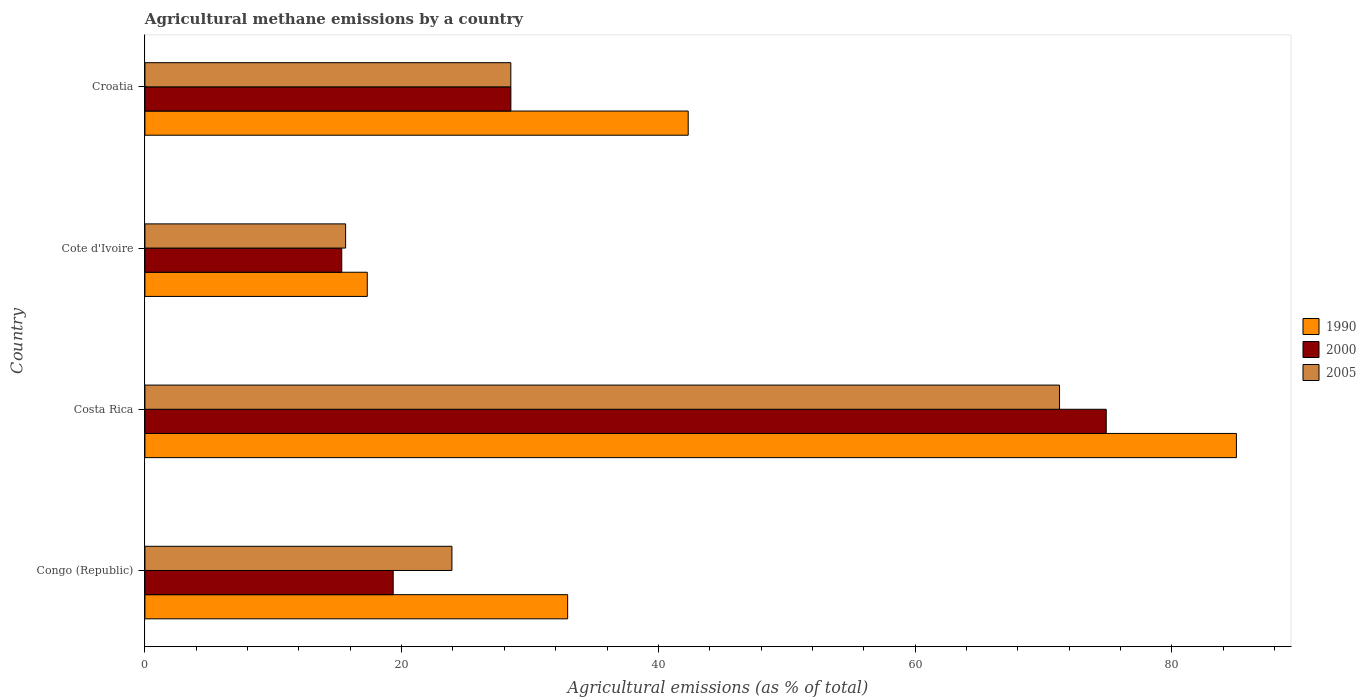How many different coloured bars are there?
Your answer should be compact. 3. How many groups of bars are there?
Make the answer very short. 4. How many bars are there on the 1st tick from the top?
Keep it short and to the point. 3. What is the label of the 2nd group of bars from the top?
Keep it short and to the point. Cote d'Ivoire. In how many cases, is the number of bars for a given country not equal to the number of legend labels?
Provide a short and direct response. 0. What is the amount of agricultural methane emitted in 1990 in Croatia?
Your response must be concise. 42.33. Across all countries, what is the maximum amount of agricultural methane emitted in 2000?
Keep it short and to the point. 74.89. Across all countries, what is the minimum amount of agricultural methane emitted in 2000?
Give a very brief answer. 15.33. In which country was the amount of agricultural methane emitted in 2005 maximum?
Offer a terse response. Costa Rica. In which country was the amount of agricultural methane emitted in 2000 minimum?
Give a very brief answer. Cote d'Ivoire. What is the total amount of agricultural methane emitted in 2005 in the graph?
Give a very brief answer. 139.32. What is the difference between the amount of agricultural methane emitted in 1990 in Congo (Republic) and that in Cote d'Ivoire?
Ensure brevity in your answer.  15.61. What is the difference between the amount of agricultural methane emitted in 2000 in Cote d'Ivoire and the amount of agricultural methane emitted in 1990 in Costa Rica?
Your answer should be compact. -69.7. What is the average amount of agricultural methane emitted in 2005 per country?
Your response must be concise. 34.83. What is the difference between the amount of agricultural methane emitted in 2000 and amount of agricultural methane emitted in 1990 in Congo (Republic)?
Provide a short and direct response. -13.59. In how many countries, is the amount of agricultural methane emitted in 2000 greater than 28 %?
Ensure brevity in your answer.  2. What is the ratio of the amount of agricultural methane emitted in 2005 in Costa Rica to that in Croatia?
Offer a very short reply. 2.5. What is the difference between the highest and the second highest amount of agricultural methane emitted in 2005?
Make the answer very short. 42.75. What is the difference between the highest and the lowest amount of agricultural methane emitted in 2005?
Offer a terse response. 55.62. Is the sum of the amount of agricultural methane emitted in 1990 in Congo (Republic) and Croatia greater than the maximum amount of agricultural methane emitted in 2000 across all countries?
Offer a terse response. Yes. What does the 3rd bar from the top in Cote d'Ivoire represents?
Your answer should be compact. 1990. What does the 2nd bar from the bottom in Cote d'Ivoire represents?
Provide a succinct answer. 2000. Is it the case that in every country, the sum of the amount of agricultural methane emitted in 1990 and amount of agricultural methane emitted in 2005 is greater than the amount of agricultural methane emitted in 2000?
Keep it short and to the point. Yes. Are all the bars in the graph horizontal?
Your response must be concise. Yes. How many countries are there in the graph?
Offer a very short reply. 4. Where does the legend appear in the graph?
Keep it short and to the point. Center right. How many legend labels are there?
Your answer should be very brief. 3. How are the legend labels stacked?
Your answer should be compact. Vertical. What is the title of the graph?
Ensure brevity in your answer.  Agricultural methane emissions by a country. Does "1967" appear as one of the legend labels in the graph?
Your answer should be compact. No. What is the label or title of the X-axis?
Your response must be concise. Agricultural emissions (as % of total). What is the label or title of the Y-axis?
Make the answer very short. Country. What is the Agricultural emissions (as % of total) in 1990 in Congo (Republic)?
Provide a succinct answer. 32.93. What is the Agricultural emissions (as % of total) in 2000 in Congo (Republic)?
Offer a terse response. 19.34. What is the Agricultural emissions (as % of total) in 2005 in Congo (Republic)?
Give a very brief answer. 23.92. What is the Agricultural emissions (as % of total) of 1990 in Costa Rica?
Your answer should be very brief. 85.04. What is the Agricultural emissions (as % of total) in 2000 in Costa Rica?
Keep it short and to the point. 74.89. What is the Agricultural emissions (as % of total) in 2005 in Costa Rica?
Give a very brief answer. 71.26. What is the Agricultural emissions (as % of total) of 1990 in Cote d'Ivoire?
Provide a succinct answer. 17.32. What is the Agricultural emissions (as % of total) of 2000 in Cote d'Ivoire?
Your response must be concise. 15.33. What is the Agricultural emissions (as % of total) in 2005 in Cote d'Ivoire?
Your response must be concise. 15.64. What is the Agricultural emissions (as % of total) in 1990 in Croatia?
Give a very brief answer. 42.33. What is the Agricultural emissions (as % of total) of 2000 in Croatia?
Your answer should be compact. 28.51. What is the Agricultural emissions (as % of total) of 2005 in Croatia?
Offer a very short reply. 28.51. Across all countries, what is the maximum Agricultural emissions (as % of total) of 1990?
Offer a very short reply. 85.04. Across all countries, what is the maximum Agricultural emissions (as % of total) of 2000?
Ensure brevity in your answer.  74.89. Across all countries, what is the maximum Agricultural emissions (as % of total) of 2005?
Provide a succinct answer. 71.26. Across all countries, what is the minimum Agricultural emissions (as % of total) of 1990?
Provide a short and direct response. 17.32. Across all countries, what is the minimum Agricultural emissions (as % of total) of 2000?
Make the answer very short. 15.33. Across all countries, what is the minimum Agricultural emissions (as % of total) in 2005?
Your answer should be compact. 15.64. What is the total Agricultural emissions (as % of total) of 1990 in the graph?
Your answer should be compact. 177.62. What is the total Agricultural emissions (as % of total) in 2000 in the graph?
Provide a short and direct response. 138.08. What is the total Agricultural emissions (as % of total) of 2005 in the graph?
Provide a succinct answer. 139.32. What is the difference between the Agricultural emissions (as % of total) of 1990 in Congo (Republic) and that in Costa Rica?
Offer a terse response. -52.1. What is the difference between the Agricultural emissions (as % of total) in 2000 in Congo (Republic) and that in Costa Rica?
Your answer should be very brief. -55.55. What is the difference between the Agricultural emissions (as % of total) of 2005 in Congo (Republic) and that in Costa Rica?
Provide a short and direct response. -47.34. What is the difference between the Agricultural emissions (as % of total) of 1990 in Congo (Republic) and that in Cote d'Ivoire?
Provide a short and direct response. 15.61. What is the difference between the Agricultural emissions (as % of total) in 2000 in Congo (Republic) and that in Cote d'Ivoire?
Ensure brevity in your answer.  4.01. What is the difference between the Agricultural emissions (as % of total) of 2005 in Congo (Republic) and that in Cote d'Ivoire?
Make the answer very short. 8.28. What is the difference between the Agricultural emissions (as % of total) in 1990 in Congo (Republic) and that in Croatia?
Your answer should be very brief. -9.39. What is the difference between the Agricultural emissions (as % of total) of 2000 in Congo (Republic) and that in Croatia?
Keep it short and to the point. -9.17. What is the difference between the Agricultural emissions (as % of total) of 2005 in Congo (Republic) and that in Croatia?
Offer a very short reply. -4.59. What is the difference between the Agricultural emissions (as % of total) of 1990 in Costa Rica and that in Cote d'Ivoire?
Keep it short and to the point. 67.71. What is the difference between the Agricultural emissions (as % of total) in 2000 in Costa Rica and that in Cote d'Ivoire?
Keep it short and to the point. 59.56. What is the difference between the Agricultural emissions (as % of total) in 2005 in Costa Rica and that in Cote d'Ivoire?
Offer a very short reply. 55.62. What is the difference between the Agricultural emissions (as % of total) of 1990 in Costa Rica and that in Croatia?
Provide a short and direct response. 42.71. What is the difference between the Agricultural emissions (as % of total) of 2000 in Costa Rica and that in Croatia?
Make the answer very short. 46.38. What is the difference between the Agricultural emissions (as % of total) of 2005 in Costa Rica and that in Croatia?
Provide a succinct answer. 42.75. What is the difference between the Agricultural emissions (as % of total) of 1990 in Cote d'Ivoire and that in Croatia?
Make the answer very short. -25. What is the difference between the Agricultural emissions (as % of total) in 2000 in Cote d'Ivoire and that in Croatia?
Your response must be concise. -13.18. What is the difference between the Agricultural emissions (as % of total) of 2005 in Cote d'Ivoire and that in Croatia?
Give a very brief answer. -12.87. What is the difference between the Agricultural emissions (as % of total) in 1990 in Congo (Republic) and the Agricultural emissions (as % of total) in 2000 in Costa Rica?
Give a very brief answer. -41.96. What is the difference between the Agricultural emissions (as % of total) of 1990 in Congo (Republic) and the Agricultural emissions (as % of total) of 2005 in Costa Rica?
Provide a succinct answer. -38.32. What is the difference between the Agricultural emissions (as % of total) of 2000 in Congo (Republic) and the Agricultural emissions (as % of total) of 2005 in Costa Rica?
Offer a terse response. -51.91. What is the difference between the Agricultural emissions (as % of total) in 1990 in Congo (Republic) and the Agricultural emissions (as % of total) in 2000 in Cote d'Ivoire?
Make the answer very short. 17.6. What is the difference between the Agricultural emissions (as % of total) in 1990 in Congo (Republic) and the Agricultural emissions (as % of total) in 2005 in Cote d'Ivoire?
Give a very brief answer. 17.3. What is the difference between the Agricultural emissions (as % of total) of 2000 in Congo (Republic) and the Agricultural emissions (as % of total) of 2005 in Cote d'Ivoire?
Offer a very short reply. 3.71. What is the difference between the Agricultural emissions (as % of total) in 1990 in Congo (Republic) and the Agricultural emissions (as % of total) in 2000 in Croatia?
Your response must be concise. 4.42. What is the difference between the Agricultural emissions (as % of total) in 1990 in Congo (Republic) and the Agricultural emissions (as % of total) in 2005 in Croatia?
Provide a succinct answer. 4.43. What is the difference between the Agricultural emissions (as % of total) in 2000 in Congo (Republic) and the Agricultural emissions (as % of total) in 2005 in Croatia?
Your answer should be very brief. -9.16. What is the difference between the Agricultural emissions (as % of total) of 1990 in Costa Rica and the Agricultural emissions (as % of total) of 2000 in Cote d'Ivoire?
Keep it short and to the point. 69.7. What is the difference between the Agricultural emissions (as % of total) of 1990 in Costa Rica and the Agricultural emissions (as % of total) of 2005 in Cote d'Ivoire?
Your answer should be very brief. 69.4. What is the difference between the Agricultural emissions (as % of total) in 2000 in Costa Rica and the Agricultural emissions (as % of total) in 2005 in Cote d'Ivoire?
Your answer should be compact. 59.26. What is the difference between the Agricultural emissions (as % of total) of 1990 in Costa Rica and the Agricultural emissions (as % of total) of 2000 in Croatia?
Provide a short and direct response. 56.53. What is the difference between the Agricultural emissions (as % of total) in 1990 in Costa Rica and the Agricultural emissions (as % of total) in 2005 in Croatia?
Offer a very short reply. 56.53. What is the difference between the Agricultural emissions (as % of total) in 2000 in Costa Rica and the Agricultural emissions (as % of total) in 2005 in Croatia?
Make the answer very short. 46.39. What is the difference between the Agricultural emissions (as % of total) in 1990 in Cote d'Ivoire and the Agricultural emissions (as % of total) in 2000 in Croatia?
Keep it short and to the point. -11.19. What is the difference between the Agricultural emissions (as % of total) in 1990 in Cote d'Ivoire and the Agricultural emissions (as % of total) in 2005 in Croatia?
Make the answer very short. -11.18. What is the difference between the Agricultural emissions (as % of total) of 2000 in Cote d'Ivoire and the Agricultural emissions (as % of total) of 2005 in Croatia?
Your response must be concise. -13.17. What is the average Agricultural emissions (as % of total) in 1990 per country?
Make the answer very short. 44.41. What is the average Agricultural emissions (as % of total) in 2000 per country?
Your answer should be very brief. 34.52. What is the average Agricultural emissions (as % of total) of 2005 per country?
Ensure brevity in your answer.  34.83. What is the difference between the Agricultural emissions (as % of total) of 1990 and Agricultural emissions (as % of total) of 2000 in Congo (Republic)?
Your answer should be compact. 13.59. What is the difference between the Agricultural emissions (as % of total) in 1990 and Agricultural emissions (as % of total) in 2005 in Congo (Republic)?
Offer a terse response. 9.02. What is the difference between the Agricultural emissions (as % of total) in 2000 and Agricultural emissions (as % of total) in 2005 in Congo (Republic)?
Your answer should be compact. -4.58. What is the difference between the Agricultural emissions (as % of total) of 1990 and Agricultural emissions (as % of total) of 2000 in Costa Rica?
Ensure brevity in your answer.  10.14. What is the difference between the Agricultural emissions (as % of total) of 1990 and Agricultural emissions (as % of total) of 2005 in Costa Rica?
Provide a succinct answer. 13.78. What is the difference between the Agricultural emissions (as % of total) in 2000 and Agricultural emissions (as % of total) in 2005 in Costa Rica?
Provide a succinct answer. 3.64. What is the difference between the Agricultural emissions (as % of total) in 1990 and Agricultural emissions (as % of total) in 2000 in Cote d'Ivoire?
Give a very brief answer. 1.99. What is the difference between the Agricultural emissions (as % of total) in 1990 and Agricultural emissions (as % of total) in 2005 in Cote d'Ivoire?
Your answer should be compact. 1.69. What is the difference between the Agricultural emissions (as % of total) in 2000 and Agricultural emissions (as % of total) in 2005 in Cote d'Ivoire?
Provide a short and direct response. -0.3. What is the difference between the Agricultural emissions (as % of total) in 1990 and Agricultural emissions (as % of total) in 2000 in Croatia?
Keep it short and to the point. 13.82. What is the difference between the Agricultural emissions (as % of total) in 1990 and Agricultural emissions (as % of total) in 2005 in Croatia?
Provide a short and direct response. 13.82. What is the difference between the Agricultural emissions (as % of total) of 2000 and Agricultural emissions (as % of total) of 2005 in Croatia?
Make the answer very short. 0. What is the ratio of the Agricultural emissions (as % of total) of 1990 in Congo (Republic) to that in Costa Rica?
Make the answer very short. 0.39. What is the ratio of the Agricultural emissions (as % of total) in 2000 in Congo (Republic) to that in Costa Rica?
Give a very brief answer. 0.26. What is the ratio of the Agricultural emissions (as % of total) of 2005 in Congo (Republic) to that in Costa Rica?
Give a very brief answer. 0.34. What is the ratio of the Agricultural emissions (as % of total) of 1990 in Congo (Republic) to that in Cote d'Ivoire?
Your response must be concise. 1.9. What is the ratio of the Agricultural emissions (as % of total) of 2000 in Congo (Republic) to that in Cote d'Ivoire?
Your response must be concise. 1.26. What is the ratio of the Agricultural emissions (as % of total) in 2005 in Congo (Republic) to that in Cote d'Ivoire?
Ensure brevity in your answer.  1.53. What is the ratio of the Agricultural emissions (as % of total) in 1990 in Congo (Republic) to that in Croatia?
Keep it short and to the point. 0.78. What is the ratio of the Agricultural emissions (as % of total) in 2000 in Congo (Republic) to that in Croatia?
Your answer should be compact. 0.68. What is the ratio of the Agricultural emissions (as % of total) in 2005 in Congo (Republic) to that in Croatia?
Ensure brevity in your answer.  0.84. What is the ratio of the Agricultural emissions (as % of total) of 1990 in Costa Rica to that in Cote d'Ivoire?
Offer a very short reply. 4.91. What is the ratio of the Agricultural emissions (as % of total) in 2000 in Costa Rica to that in Cote d'Ivoire?
Your answer should be very brief. 4.88. What is the ratio of the Agricultural emissions (as % of total) in 2005 in Costa Rica to that in Cote d'Ivoire?
Your answer should be compact. 4.56. What is the ratio of the Agricultural emissions (as % of total) of 1990 in Costa Rica to that in Croatia?
Give a very brief answer. 2.01. What is the ratio of the Agricultural emissions (as % of total) in 2000 in Costa Rica to that in Croatia?
Give a very brief answer. 2.63. What is the ratio of the Agricultural emissions (as % of total) of 2005 in Costa Rica to that in Croatia?
Your response must be concise. 2.5. What is the ratio of the Agricultural emissions (as % of total) in 1990 in Cote d'Ivoire to that in Croatia?
Offer a terse response. 0.41. What is the ratio of the Agricultural emissions (as % of total) in 2000 in Cote d'Ivoire to that in Croatia?
Your response must be concise. 0.54. What is the ratio of the Agricultural emissions (as % of total) in 2005 in Cote d'Ivoire to that in Croatia?
Keep it short and to the point. 0.55. What is the difference between the highest and the second highest Agricultural emissions (as % of total) in 1990?
Make the answer very short. 42.71. What is the difference between the highest and the second highest Agricultural emissions (as % of total) in 2000?
Keep it short and to the point. 46.38. What is the difference between the highest and the second highest Agricultural emissions (as % of total) of 2005?
Make the answer very short. 42.75. What is the difference between the highest and the lowest Agricultural emissions (as % of total) of 1990?
Your answer should be compact. 67.71. What is the difference between the highest and the lowest Agricultural emissions (as % of total) in 2000?
Give a very brief answer. 59.56. What is the difference between the highest and the lowest Agricultural emissions (as % of total) in 2005?
Give a very brief answer. 55.62. 